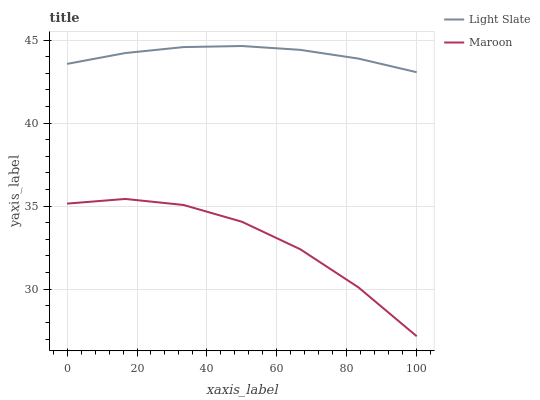Does Maroon have the minimum area under the curve?
Answer yes or no. Yes. Does Light Slate have the maximum area under the curve?
Answer yes or no. Yes. Does Maroon have the maximum area under the curve?
Answer yes or no. No. Is Light Slate the smoothest?
Answer yes or no. Yes. Is Maroon the roughest?
Answer yes or no. Yes. Is Maroon the smoothest?
Answer yes or no. No. Does Light Slate have the highest value?
Answer yes or no. Yes. Does Maroon have the highest value?
Answer yes or no. No. Is Maroon less than Light Slate?
Answer yes or no. Yes. Is Light Slate greater than Maroon?
Answer yes or no. Yes. Does Maroon intersect Light Slate?
Answer yes or no. No. 